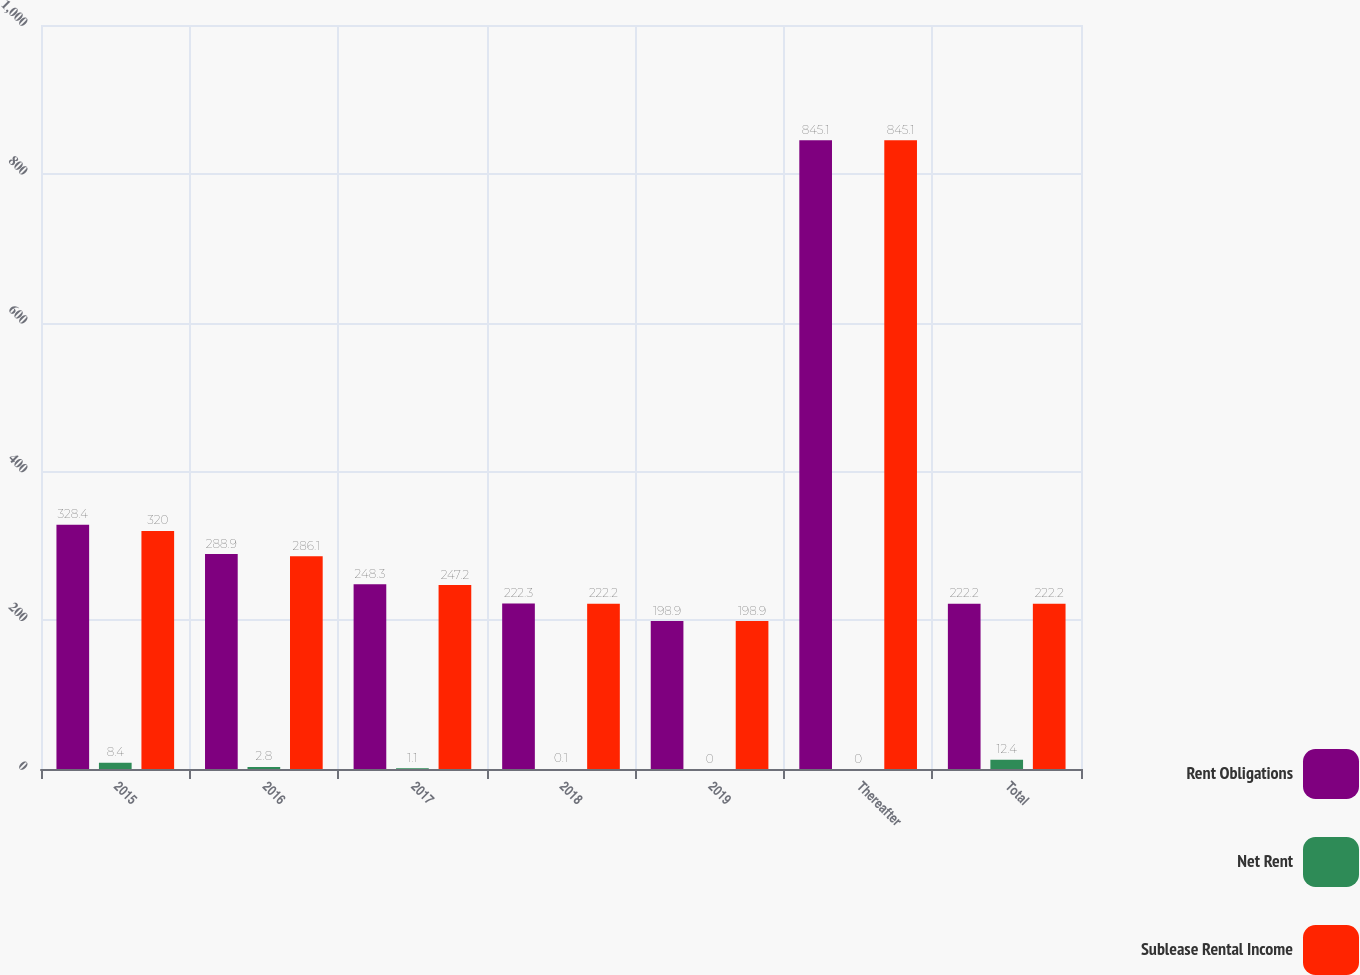Convert chart. <chart><loc_0><loc_0><loc_500><loc_500><stacked_bar_chart><ecel><fcel>2015<fcel>2016<fcel>2017<fcel>2018<fcel>2019<fcel>Thereafter<fcel>Total<nl><fcel>Rent Obligations<fcel>328.4<fcel>288.9<fcel>248.3<fcel>222.3<fcel>198.9<fcel>845.1<fcel>222.2<nl><fcel>Net Rent<fcel>8.4<fcel>2.8<fcel>1.1<fcel>0.1<fcel>0<fcel>0<fcel>12.4<nl><fcel>Sublease Rental Income<fcel>320<fcel>286.1<fcel>247.2<fcel>222.2<fcel>198.9<fcel>845.1<fcel>222.2<nl></chart> 